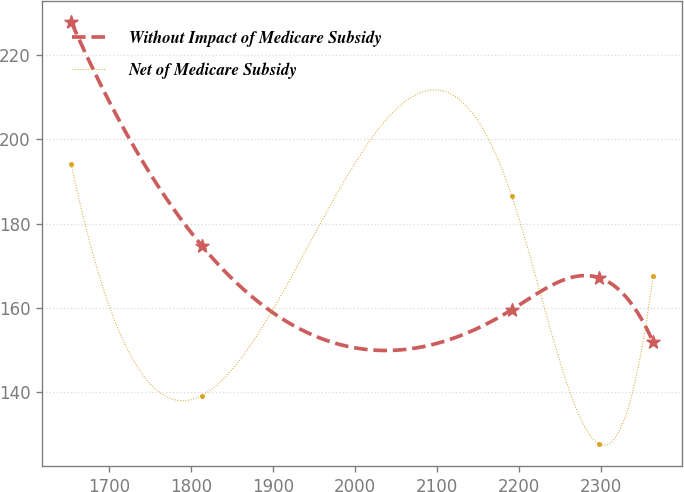Convert chart. <chart><loc_0><loc_0><loc_500><loc_500><line_chart><ecel><fcel>Without Impact of Medicare Subsidy<fcel>Net of Medicare Subsidy<nl><fcel>1654.1<fcel>227.89<fcel>194.07<nl><fcel>1813.37<fcel>174.72<fcel>139.14<nl><fcel>2191.41<fcel>159.53<fcel>186.64<nl><fcel>2298.31<fcel>167.12<fcel>127.6<nl><fcel>2363.75<fcel>151.94<fcel>167.53<nl></chart> 